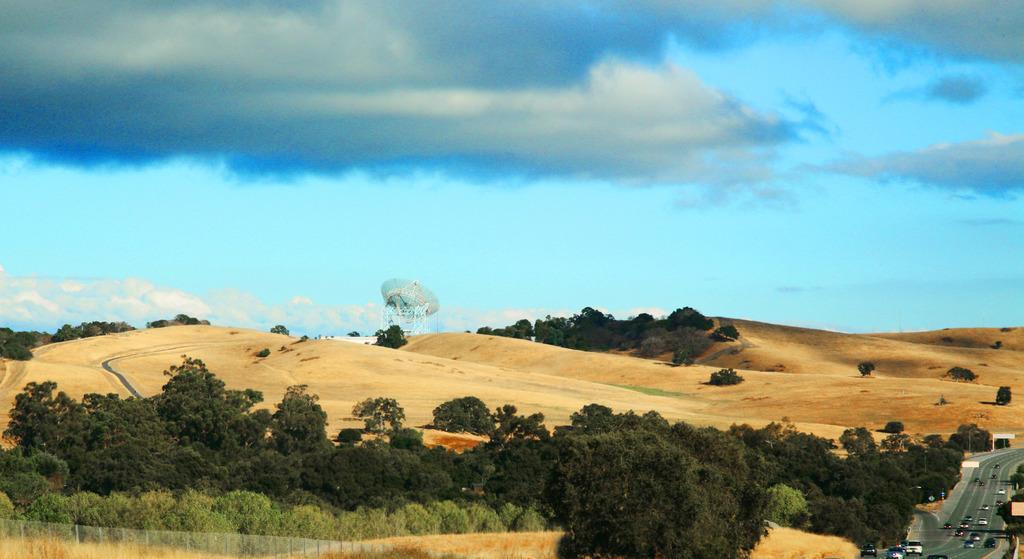In one or two sentences, can you explain what this image depicts? This is a out side image where we can see a blue sky at the top of the image. In the bottom right corner of the image I can see a road with the vehicles and I can see desert all over the image and I can see plants at the bottom of the image. 